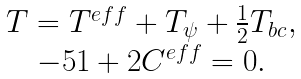Convert formula to latex. <formula><loc_0><loc_0><loc_500><loc_500>\begin{array} { c } T = T ^ { e f f } + T _ { \psi } + \frac { 1 } { 2 } T _ { b c } , \\ - 5 1 + 2 C ^ { e f f } = 0 . \\ \end{array}</formula> 